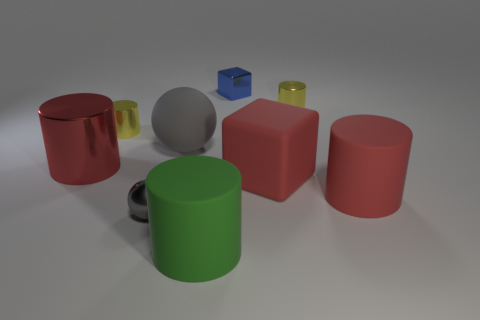Subtract all yellow metallic cylinders. How many cylinders are left? 3 Subtract all green spheres. How many yellow cylinders are left? 2 Subtract all red cylinders. How many cylinders are left? 3 Subtract all balls. How many objects are left? 7 Subtract all blue cylinders. Subtract all blue balls. How many cylinders are left? 5 Subtract 1 gray spheres. How many objects are left? 8 Subtract all big green things. Subtract all small gray metallic balls. How many objects are left? 7 Add 1 metallic spheres. How many metallic spheres are left? 2 Add 7 cyan cylinders. How many cyan cylinders exist? 7 